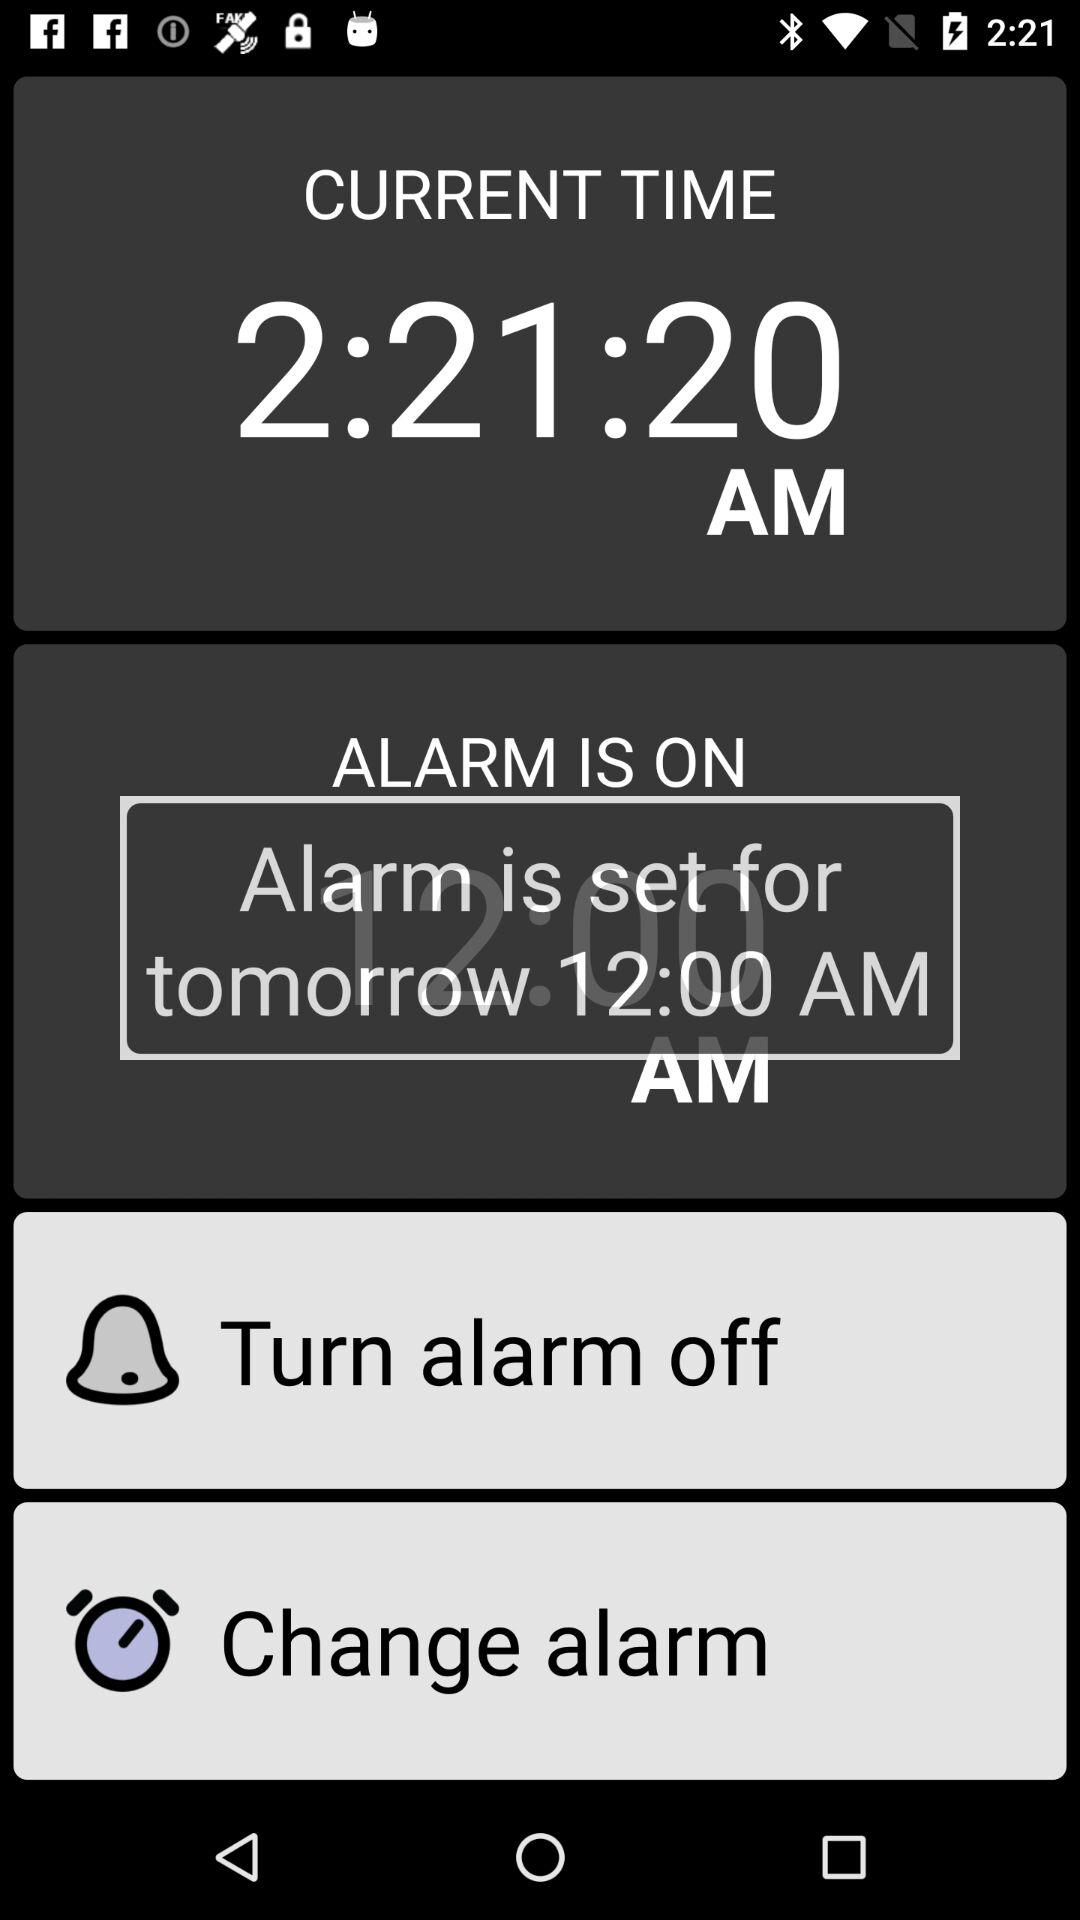Is the alarm on or off? The alarm is on. 